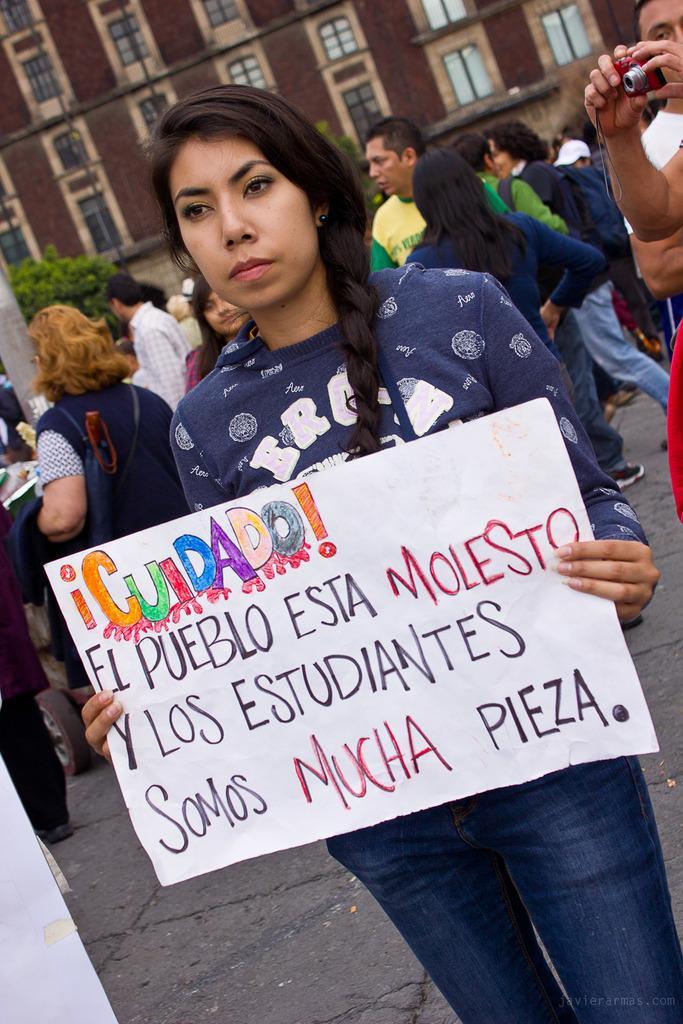Describe this image in one or two sentences. In the center of the image we can see a lady standing and holding a board. In the background there are people. On the right we can see a person's hands holding a camera. In the background there is a building. On the left there is a tree. 